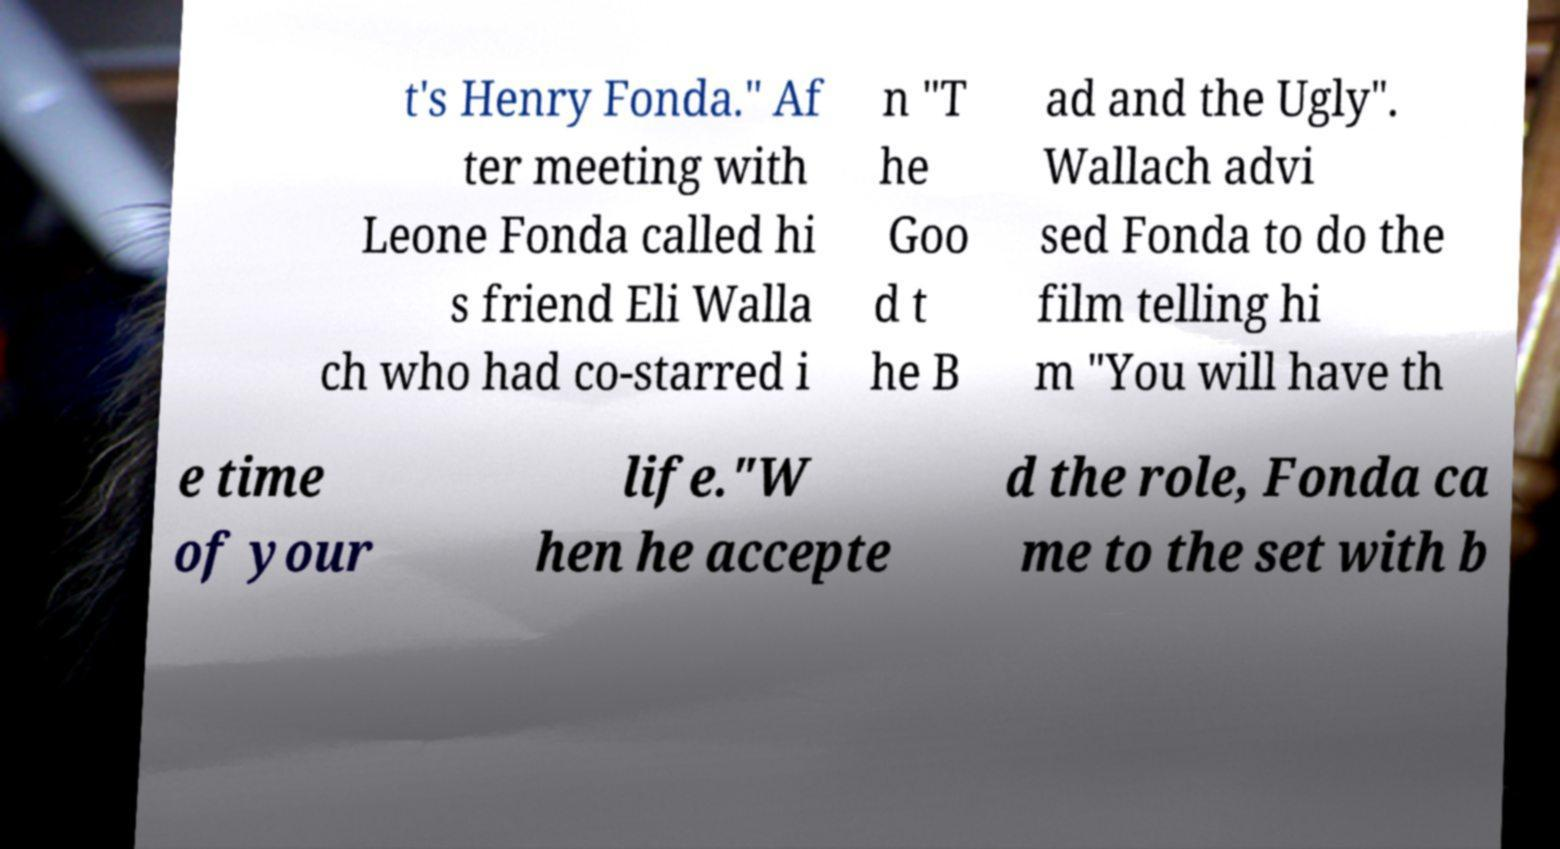Can you accurately transcribe the text from the provided image for me? t's Henry Fonda." Af ter meeting with Leone Fonda called hi s friend Eli Walla ch who had co-starred i n "T he Goo d t he B ad and the Ugly". Wallach advi sed Fonda to do the film telling hi m "You will have th e time of your life."W hen he accepte d the role, Fonda ca me to the set with b 